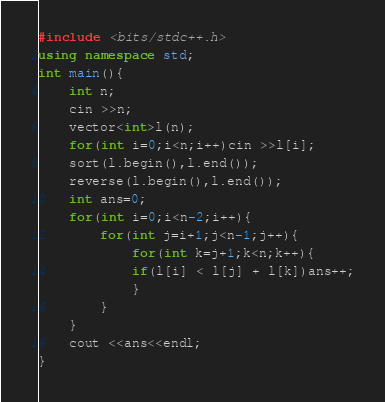<code> <loc_0><loc_0><loc_500><loc_500><_C++_>#include <bits/stdc++.h>
using namespace std;
int main(){
    int n;
    cin >>n;
    vector<int>l(n);
    for(int i=0;i<n;i++)cin >>l[i];
    sort(l.begin(),l.end());
    reverse(l.begin(),l.end());
    int ans=0;
    for(int i=0;i<n-2;i++){
        for(int j=i+1;j<n-1;j++){
            for(int k=j+1;k<n;k++){
            if(l[i] < l[j] + l[k])ans++;
            }
        }
    }
    cout <<ans<<endl;
}</code> 